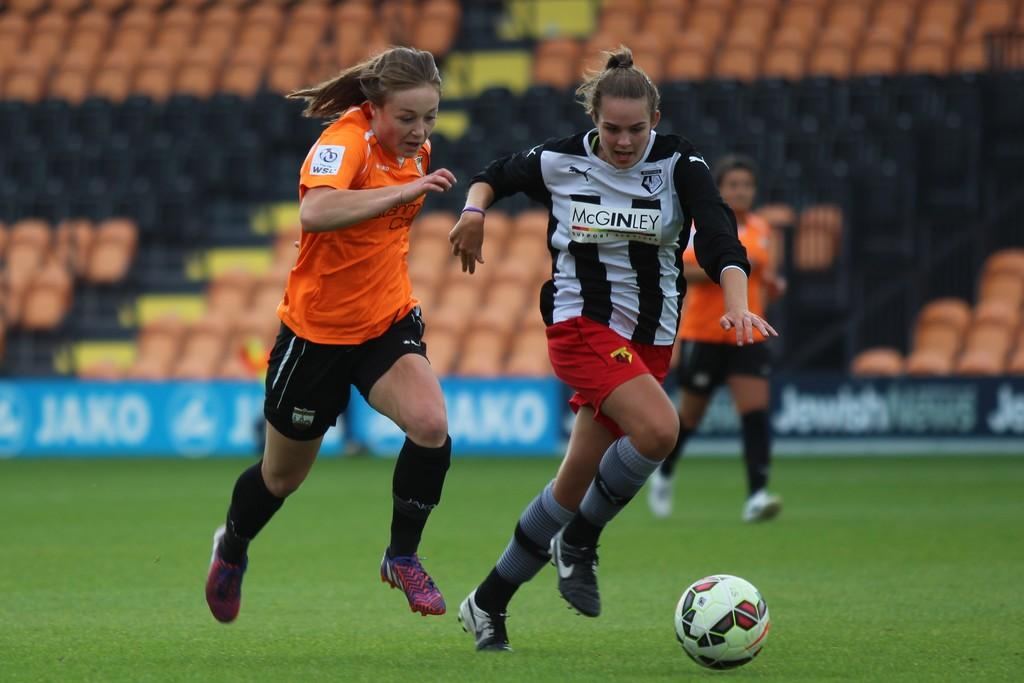<image>
Provide a brief description of the given image. A female soccer player with the word Mcginley on her shirt 